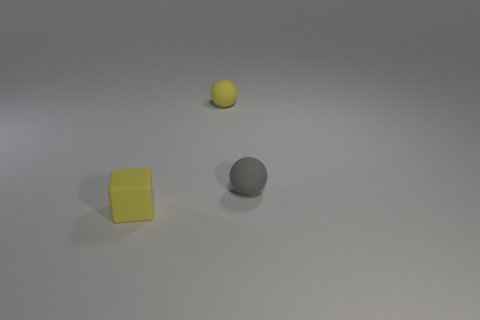Add 2 cyan rubber things. How many objects exist? 5 Subtract all spheres. How many objects are left? 1 Subtract all cyan cubes. Subtract all gray spheres. How many cubes are left? 1 Subtract all cyan cubes. How many purple spheres are left? 0 Subtract all small yellow balls. Subtract all green metal cubes. How many objects are left? 2 Add 1 yellow things. How many yellow things are left? 3 Add 3 small yellow matte things. How many small yellow matte things exist? 5 Subtract 0 green blocks. How many objects are left? 3 